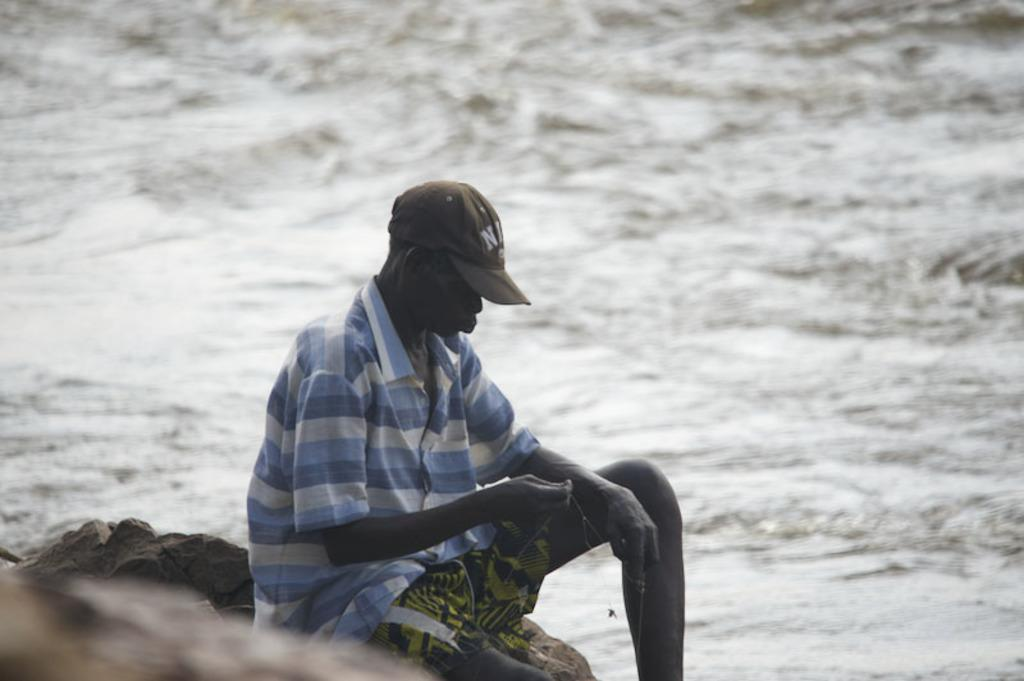Who or what is present in the image? There is a person in the image. What is the person wearing on their head? The person is wearing a cap. Where is the person sitting? The person is sitting on a rock. What is the person holding in their hand? The person is holding an object in their hand. What can be seen near the person? There is water visible beside the person. What type of rod can be seen in the person's hand in the image? There is no rod visible in the person's hand in the image. What is the chance of the person standing up and walking away in the image? The image is a still image, so it does not show any movement or changes in the person's actions. 